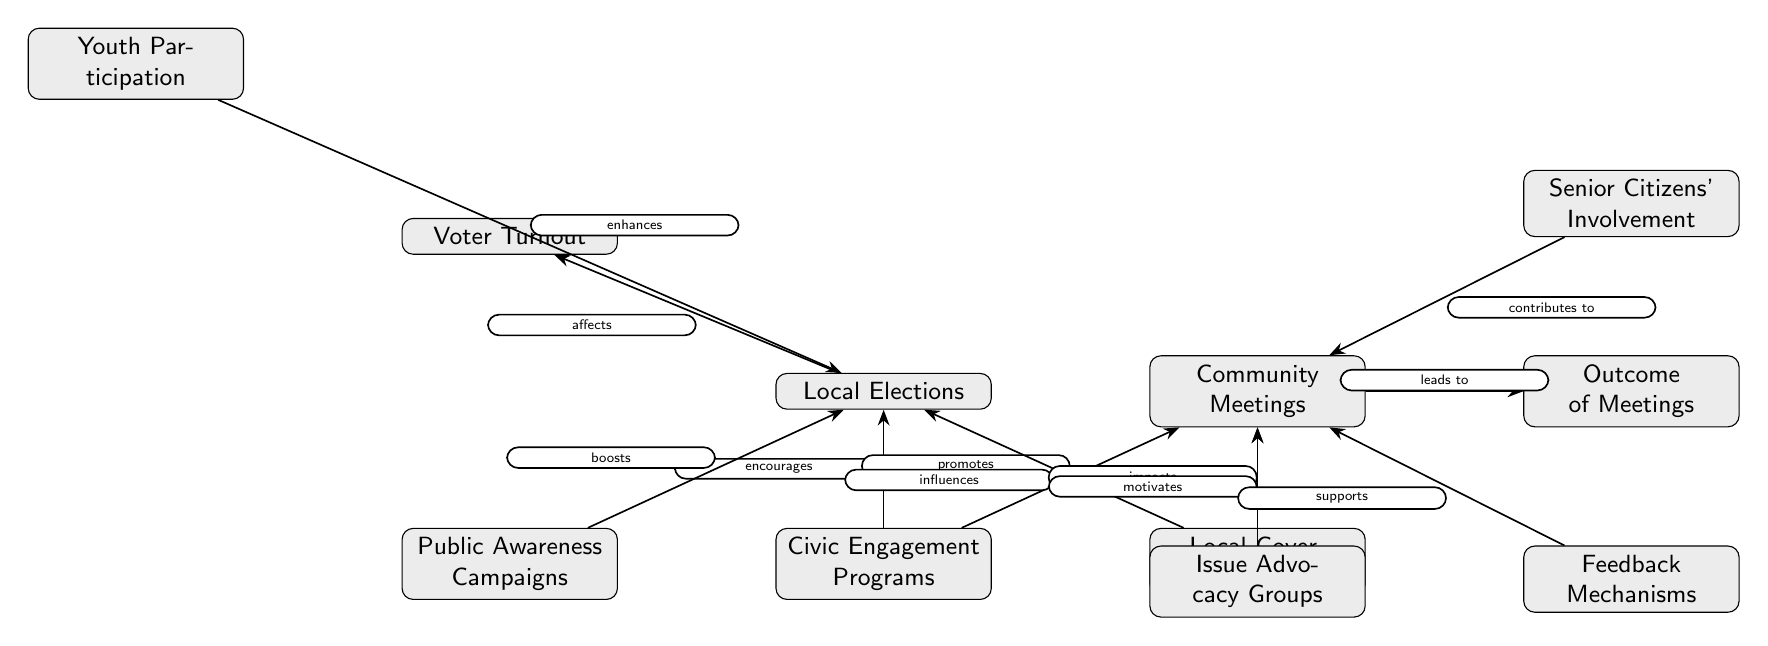What are the two main categories represented in the diagram? The diagram features two main categories: "Local Elections" and "Community Meetings," which are positioned on the first level of the diagram.
Answer: Local Elections, Community Meetings Which node affects voter turnout? The node "Local Elections" affects "Voter Turnout" as indicated by the directed edge labeled "affects" connecting them.
Answer: Local Elections How many feedback mechanisms are present in the diagram? There is one specific node indicating "Feedback Mechanisms" in the diagram, shown below "Community Meetings."
Answer: 1 What do civic engagement programs promote? "Civic Engagement Programs" promote both "Local Elections" and "Community Meetings," as shown by the arrows labeled "promotes" stemming from the "Civic Engagement Programs" node.
Answer: Local Elections, Community Meetings Which group motivates participation in community meetings? "Issue Advocacy Groups" are the group that motivates participation in "Community Meetings," as shown by the arrow connecting them labeled "motivates."
Answer: Issue Advocacy Groups Which demographic enhances voter turnout? "Youth Participation" enhances "Voter Turnout," evident from the directed edge connecting "Youth Participation" to "Voter Turnout" with the label "enhances."
Answer: Youth Participation What is the relationship between local governance trust and community meetings? "Local Governance Trust" impacts "Community Meetings," as indicated by the directed edge labeled "impacts."
Answer: impacts How many nodes are related to community meetings? There are four nodes related to "Community Meetings": "Outcome of Meetings," "Feedback Mechanisms," "Issue Advocacy Groups," and "Senior Citizens' Involvement."
Answer: 4 Which node is associated with public awareness campaigns? The "Public Awareness Campaigns" node is associated with "Civic Engagement Programs," as it boosts participation in "Local Elections" according to the directed edge labeled "boosts."
Answer: Civic Engagement Programs 